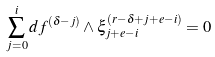<formula> <loc_0><loc_0><loc_500><loc_500>\sum _ { j = 0 } ^ { i } d f ^ { ( \delta - j ) } \wedge \xi _ { j + e - i } ^ { ( r - \delta + j + e - i ) } = 0</formula> 